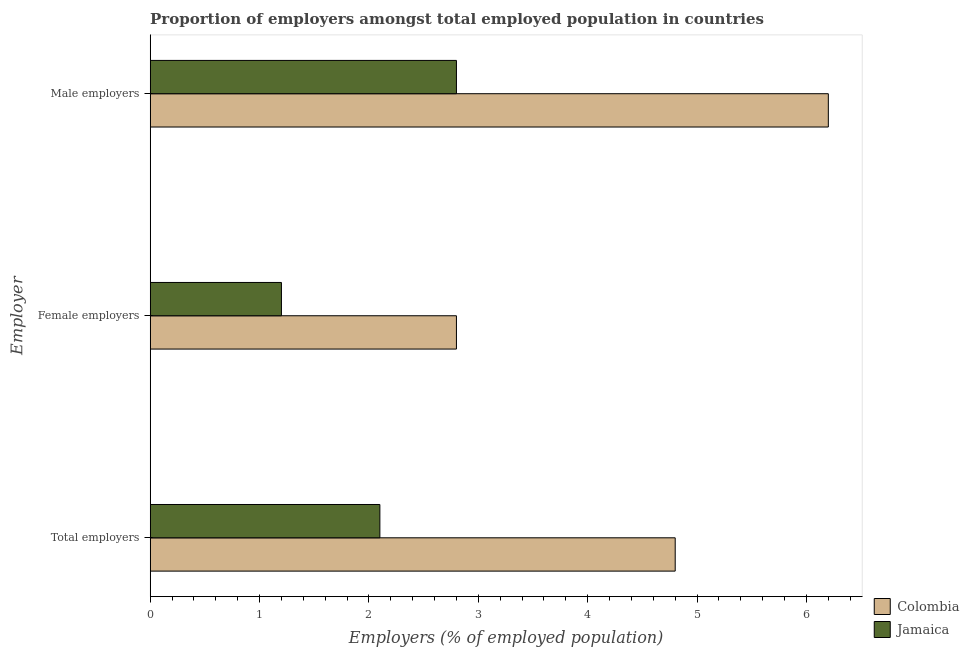How many groups of bars are there?
Offer a terse response. 3. Are the number of bars per tick equal to the number of legend labels?
Offer a terse response. Yes. Are the number of bars on each tick of the Y-axis equal?
Provide a succinct answer. Yes. How many bars are there on the 1st tick from the top?
Your answer should be compact. 2. What is the label of the 1st group of bars from the top?
Make the answer very short. Male employers. What is the percentage of female employers in Jamaica?
Offer a terse response. 1.2. Across all countries, what is the maximum percentage of total employers?
Keep it short and to the point. 4.8. Across all countries, what is the minimum percentage of total employers?
Your answer should be compact. 2.1. In which country was the percentage of male employers minimum?
Provide a short and direct response. Jamaica. What is the total percentage of male employers in the graph?
Your answer should be very brief. 9. What is the difference between the percentage of male employers in Colombia and that in Jamaica?
Provide a succinct answer. 3.4. What is the difference between the percentage of total employers in Colombia and the percentage of female employers in Jamaica?
Provide a short and direct response. 3.6. What is the average percentage of total employers per country?
Offer a terse response. 3.45. What is the difference between the percentage of female employers and percentage of male employers in Colombia?
Make the answer very short. -3.4. In how many countries, is the percentage of female employers greater than 2.4 %?
Provide a succinct answer. 1. What is the ratio of the percentage of female employers in Colombia to that in Jamaica?
Keep it short and to the point. 2.33. Is the difference between the percentage of male employers in Colombia and Jamaica greater than the difference between the percentage of total employers in Colombia and Jamaica?
Your answer should be very brief. Yes. What is the difference between the highest and the second highest percentage of male employers?
Provide a short and direct response. 3.4. What is the difference between the highest and the lowest percentage of female employers?
Give a very brief answer. 1.6. What does the 2nd bar from the top in Male employers represents?
Make the answer very short. Colombia. What does the 1st bar from the bottom in Male employers represents?
Offer a terse response. Colombia. How many bars are there?
Your answer should be very brief. 6. Are all the bars in the graph horizontal?
Offer a terse response. Yes. How many countries are there in the graph?
Keep it short and to the point. 2. Are the values on the major ticks of X-axis written in scientific E-notation?
Provide a short and direct response. No. Does the graph contain grids?
Make the answer very short. No. What is the title of the graph?
Your answer should be compact. Proportion of employers amongst total employed population in countries. Does "Cayman Islands" appear as one of the legend labels in the graph?
Offer a very short reply. No. What is the label or title of the X-axis?
Give a very brief answer. Employers (% of employed population). What is the label or title of the Y-axis?
Offer a terse response. Employer. What is the Employers (% of employed population) of Colombia in Total employers?
Offer a very short reply. 4.8. What is the Employers (% of employed population) in Jamaica in Total employers?
Ensure brevity in your answer.  2.1. What is the Employers (% of employed population) in Colombia in Female employers?
Offer a very short reply. 2.8. What is the Employers (% of employed population) in Jamaica in Female employers?
Make the answer very short. 1.2. What is the Employers (% of employed population) of Colombia in Male employers?
Offer a terse response. 6.2. What is the Employers (% of employed population) of Jamaica in Male employers?
Make the answer very short. 2.8. Across all Employer, what is the maximum Employers (% of employed population) in Colombia?
Make the answer very short. 6.2. Across all Employer, what is the maximum Employers (% of employed population) of Jamaica?
Make the answer very short. 2.8. Across all Employer, what is the minimum Employers (% of employed population) of Colombia?
Offer a terse response. 2.8. Across all Employer, what is the minimum Employers (% of employed population) of Jamaica?
Your answer should be very brief. 1.2. What is the total Employers (% of employed population) of Colombia in the graph?
Your response must be concise. 13.8. What is the total Employers (% of employed population) in Jamaica in the graph?
Provide a short and direct response. 6.1. What is the difference between the Employers (% of employed population) of Colombia in Total employers and that in Female employers?
Make the answer very short. 2. What is the difference between the Employers (% of employed population) in Colombia in Total employers and that in Male employers?
Give a very brief answer. -1.4. What is the difference between the Employers (% of employed population) in Colombia in Female employers and that in Male employers?
Make the answer very short. -3.4. What is the difference between the Employers (% of employed population) of Jamaica in Female employers and that in Male employers?
Ensure brevity in your answer.  -1.6. What is the difference between the Employers (% of employed population) of Colombia in Female employers and the Employers (% of employed population) of Jamaica in Male employers?
Keep it short and to the point. 0. What is the average Employers (% of employed population) of Colombia per Employer?
Provide a succinct answer. 4.6. What is the average Employers (% of employed population) of Jamaica per Employer?
Offer a terse response. 2.03. What is the difference between the Employers (% of employed population) of Colombia and Employers (% of employed population) of Jamaica in Total employers?
Give a very brief answer. 2.7. What is the difference between the Employers (% of employed population) of Colombia and Employers (% of employed population) of Jamaica in Male employers?
Your response must be concise. 3.4. What is the ratio of the Employers (% of employed population) in Colombia in Total employers to that in Female employers?
Offer a terse response. 1.71. What is the ratio of the Employers (% of employed population) of Jamaica in Total employers to that in Female employers?
Provide a short and direct response. 1.75. What is the ratio of the Employers (% of employed population) in Colombia in Total employers to that in Male employers?
Offer a terse response. 0.77. What is the ratio of the Employers (% of employed population) in Colombia in Female employers to that in Male employers?
Offer a very short reply. 0.45. What is the ratio of the Employers (% of employed population) of Jamaica in Female employers to that in Male employers?
Your answer should be very brief. 0.43. What is the difference between the highest and the second highest Employers (% of employed population) in Jamaica?
Provide a short and direct response. 0.7. What is the difference between the highest and the lowest Employers (% of employed population) in Jamaica?
Ensure brevity in your answer.  1.6. 